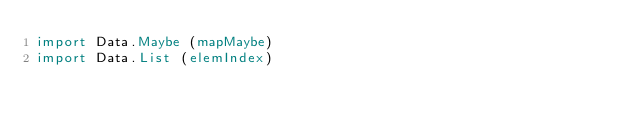<code> <loc_0><loc_0><loc_500><loc_500><_Haskell_>import Data.Maybe (mapMaybe)
import Data.List (elemIndex)
</code> 